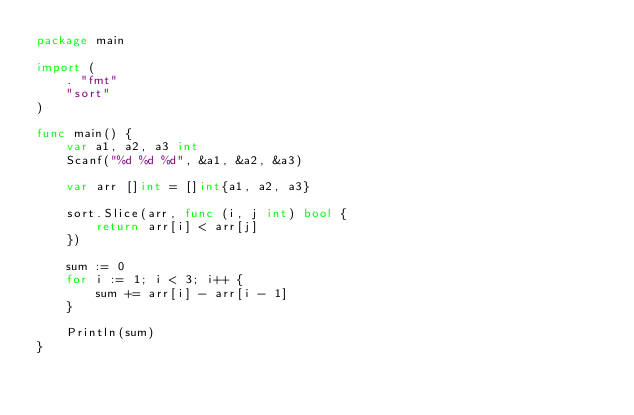<code> <loc_0><loc_0><loc_500><loc_500><_Go_>package main

import (
    . "fmt"
    "sort"
)

func main() {
    var a1, a2, a3 int
    Scanf("%d %d %d", &a1, &a2, &a3)

    var arr []int = []int{a1, a2, a3}

    sort.Slice(arr, func (i, j int) bool {
        return arr[i] < arr[j]
    })

    sum := 0
    for i := 1; i < 3; i++ {
        sum += arr[i] - arr[i - 1]
    }

    Println(sum)
}
</code> 